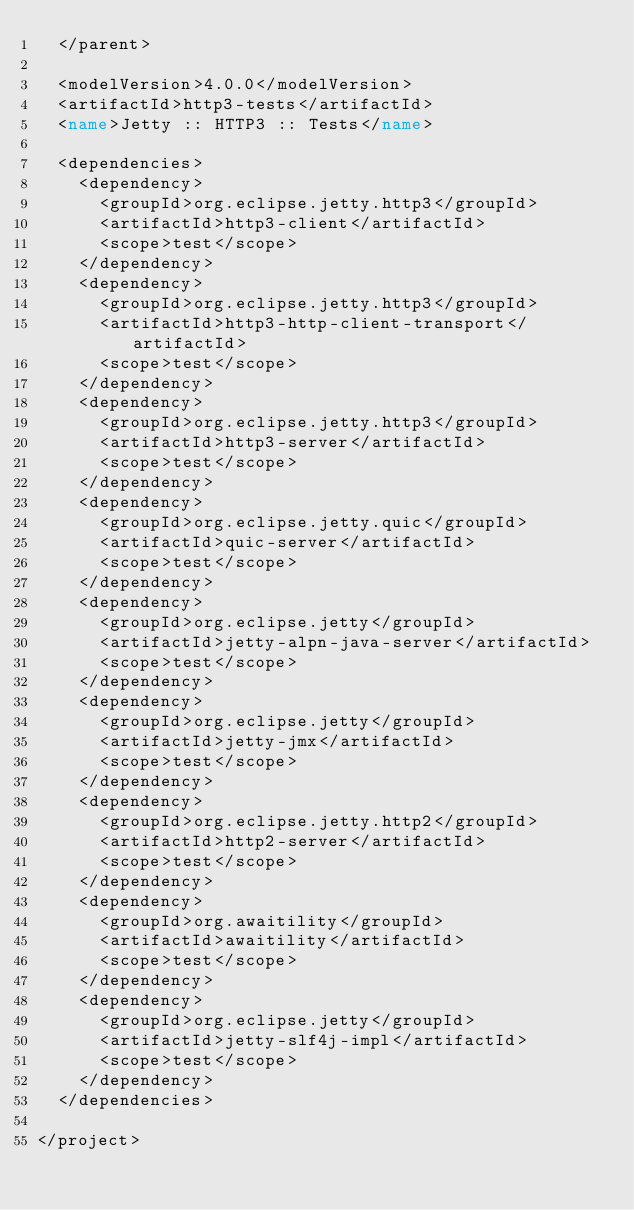<code> <loc_0><loc_0><loc_500><loc_500><_XML_>  </parent>

  <modelVersion>4.0.0</modelVersion>
  <artifactId>http3-tests</artifactId>
  <name>Jetty :: HTTP3 :: Tests</name>

  <dependencies>
    <dependency>
      <groupId>org.eclipse.jetty.http3</groupId>
      <artifactId>http3-client</artifactId>
      <scope>test</scope>
    </dependency>
    <dependency>
      <groupId>org.eclipse.jetty.http3</groupId>
      <artifactId>http3-http-client-transport</artifactId>
      <scope>test</scope>
    </dependency>
    <dependency>
      <groupId>org.eclipse.jetty.http3</groupId>
      <artifactId>http3-server</artifactId>
      <scope>test</scope>
    </dependency>
    <dependency>
      <groupId>org.eclipse.jetty.quic</groupId>
      <artifactId>quic-server</artifactId>
      <scope>test</scope>
    </dependency>
    <dependency>
      <groupId>org.eclipse.jetty</groupId>
      <artifactId>jetty-alpn-java-server</artifactId>
      <scope>test</scope>
    </dependency>
    <dependency>
      <groupId>org.eclipse.jetty</groupId>
      <artifactId>jetty-jmx</artifactId>
      <scope>test</scope>
    </dependency>
    <dependency>
      <groupId>org.eclipse.jetty.http2</groupId>
      <artifactId>http2-server</artifactId>
      <scope>test</scope>
    </dependency>
    <dependency>
      <groupId>org.awaitility</groupId>
      <artifactId>awaitility</artifactId>
      <scope>test</scope>
    </dependency>
    <dependency>
      <groupId>org.eclipse.jetty</groupId>
      <artifactId>jetty-slf4j-impl</artifactId>
      <scope>test</scope>
    </dependency>
  </dependencies>

</project>
</code> 